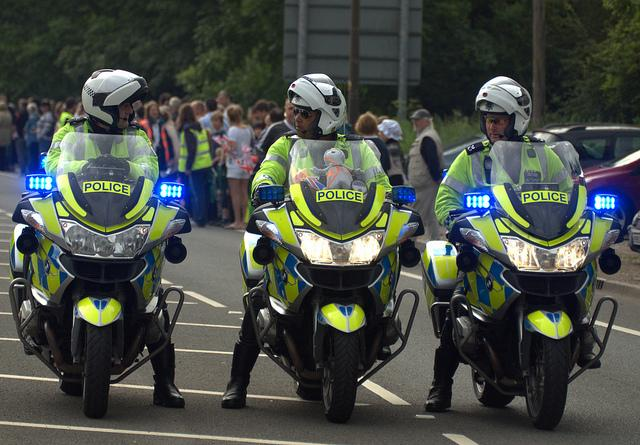Why are the bike riders wearing yellow? safety 